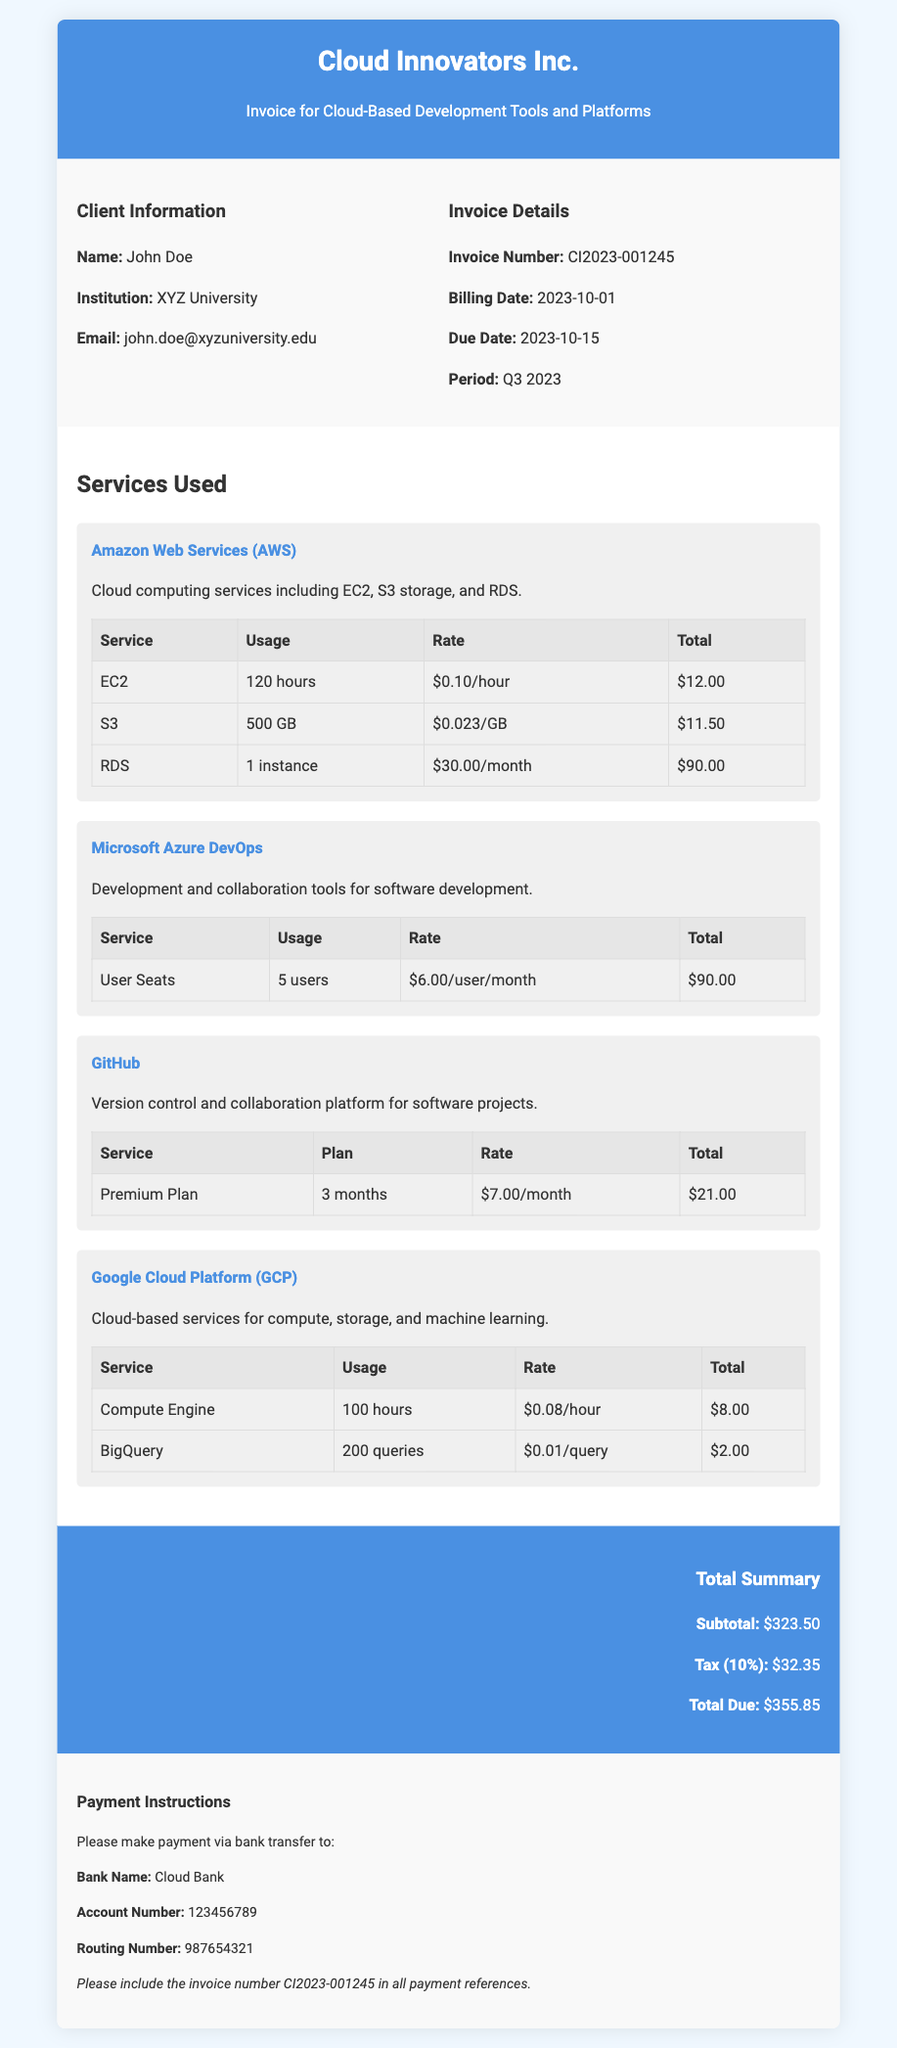What is the invoice number? The invoice number is listed prominently in the document under Invoice Details.
Answer: CI2023-001245 Who is the client? The client's name is provided in the Client Information section of the document.
Answer: John Doe What is the billing date? The billing date can be found in the Invoice Details section.
Answer: 2023-10-01 What is the total due? The total due is summarized in the Total Summary section at the bottom of the document.
Answer: $355.85 How many service items are listed? The document lists multiple service items under the Services Used section.
Answer: 4 What is the tax percentage applied? The tax percentage is indicated in the Total Summary section of the document.
Answer: 10% How much was charged for Amazon RDS? The specific charge for Amazon RDS can be found in the AWS service table.
Answer: $90.00 What payment method is accepted? The payment method can be inferred from the Payment Instructions section of the document.
Answer: Bank transfer What month is the billing period? The billing period is indicated in the Invoice Details section.
Answer: Q3 2023 How many user seats were charged for Microsoft Azure DevOps? The count of user seats is specified in the service charge table for Azure DevOps.
Answer: 5 users 